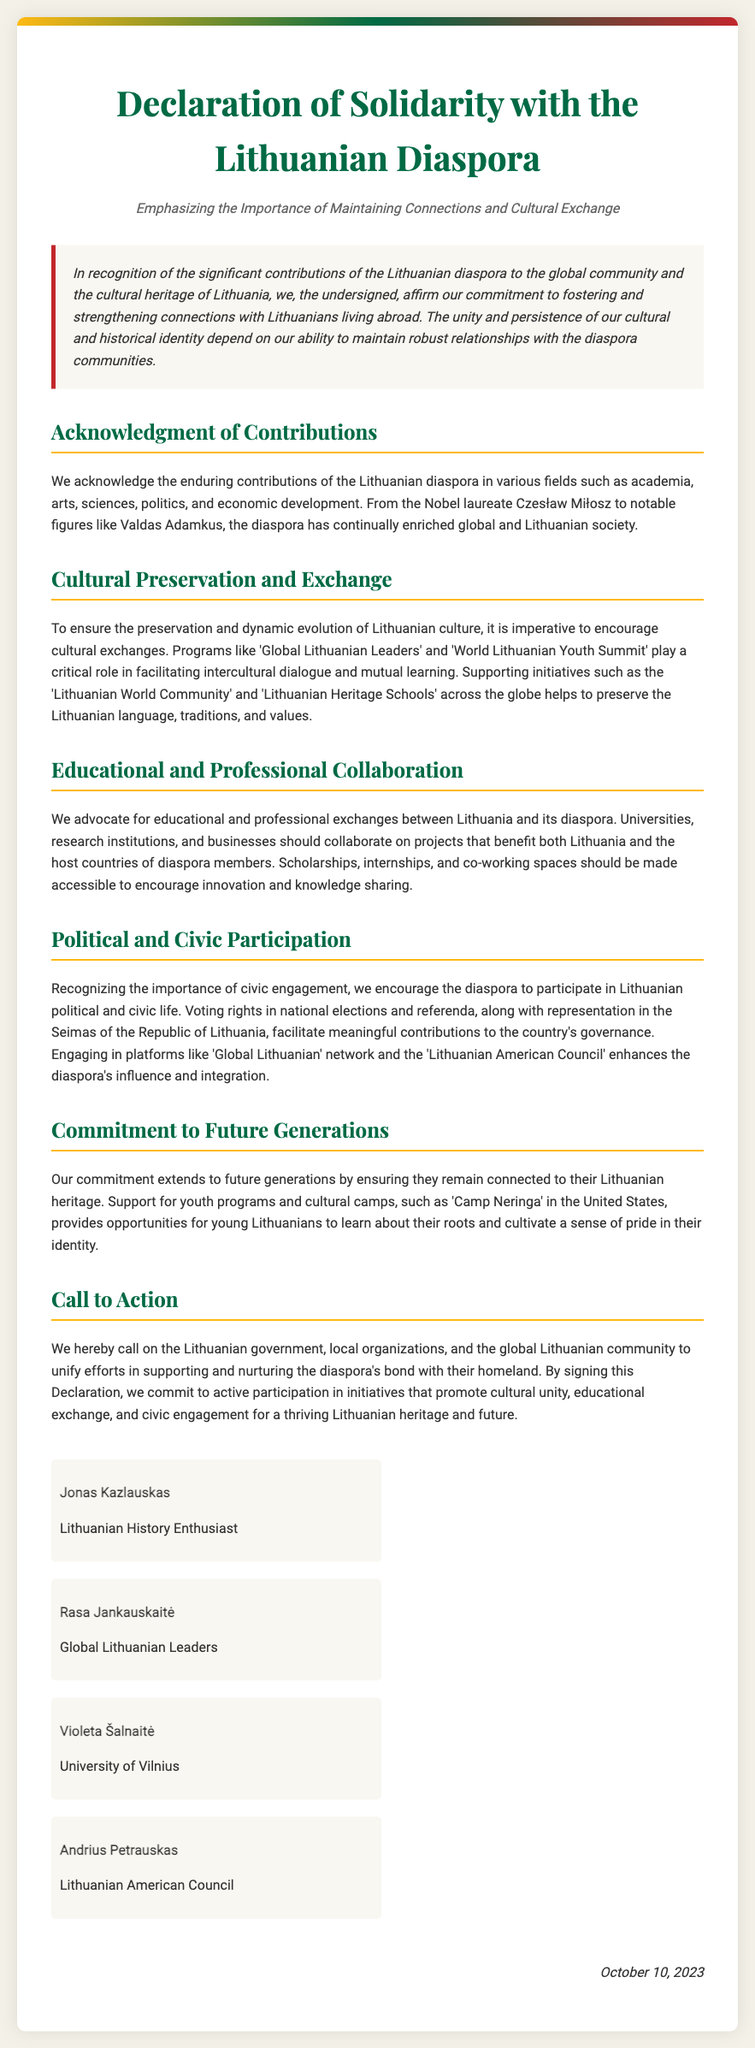What is the title of the document? The title is clearly stated at the top of the document in a large font size.
Answer: Declaration of Solidarity with the Lithuanian Diaspora What is the subtitle of the document? The subtitle is found directly under the title, providing additional context about the document's purpose.
Answer: Emphasizing the Importance of Maintaining Connections and Cultural Exchange Who is one of the signatories associated with the Lithuanian American Council? The document lists the signatories along with their affiliations.
Answer: Andrius Petrauskas What date was the declaration signed? The date is provided at the bottom of the document, signifying when it was finalized.
Answer: October 10, 2023 What program is mentioned as facilitating intercultural dialogue? The document discusses specific programs related to cultural preservation and exchanges.
Answer: Global Lithuanian Leaders What is the primary purpose of the declaration? The main objective is stated in the preamble, outlining the commitment of the undersigned.
Answer: To foster and strengthen connections with Lithuanians living abroad What type of initiatives does the declaration call on the Lithuanian government to support? The call to action section specifies the focus of the initiatives encouraged by the declaration.
Answer: Cultural unity, educational exchange, and civic engagement How many sections are in the body of the document? The document has distinct sections that cover various themes related to the diaspora.
Answer: Six sections 